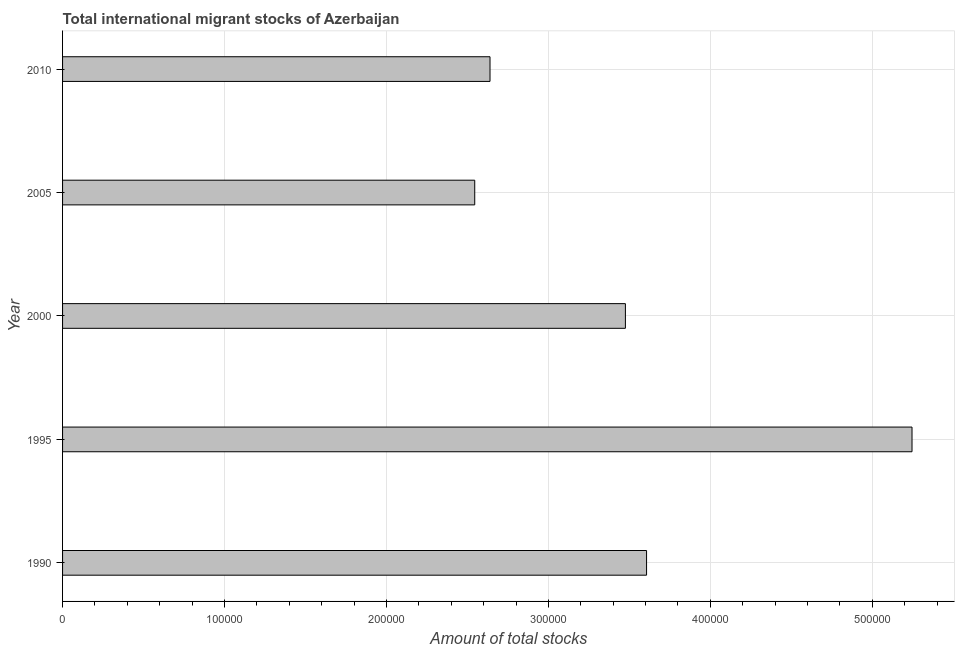Does the graph contain grids?
Offer a terse response. Yes. What is the title of the graph?
Ensure brevity in your answer.  Total international migrant stocks of Azerbaijan. What is the label or title of the X-axis?
Give a very brief answer. Amount of total stocks. What is the total number of international migrant stock in 1990?
Provide a short and direct response. 3.61e+05. Across all years, what is the maximum total number of international migrant stock?
Your answer should be compact. 5.25e+05. Across all years, what is the minimum total number of international migrant stock?
Your answer should be very brief. 2.55e+05. In which year was the total number of international migrant stock minimum?
Your answer should be very brief. 2005. What is the sum of the total number of international migrant stock?
Your answer should be compact. 1.75e+06. What is the difference between the total number of international migrant stock in 2005 and 2010?
Provide a short and direct response. -9431. What is the average total number of international migrant stock per year?
Keep it short and to the point. 3.50e+05. What is the median total number of international migrant stock?
Offer a terse response. 3.48e+05. In how many years, is the total number of international migrant stock greater than 380000 ?
Offer a terse response. 1. What is the ratio of the total number of international migrant stock in 1990 to that in 1995?
Your answer should be very brief. 0.69. Is the total number of international migrant stock in 1995 less than that in 2000?
Offer a very short reply. No. What is the difference between the highest and the second highest total number of international migrant stock?
Provide a succinct answer. 1.64e+05. What is the difference between the highest and the lowest total number of international migrant stock?
Offer a very short reply. 2.70e+05. In how many years, is the total number of international migrant stock greater than the average total number of international migrant stock taken over all years?
Ensure brevity in your answer.  2. How many bars are there?
Your answer should be compact. 5. What is the Amount of total stocks in 1990?
Provide a short and direct response. 3.61e+05. What is the Amount of total stocks of 1995?
Your answer should be very brief. 5.25e+05. What is the Amount of total stocks in 2000?
Make the answer very short. 3.48e+05. What is the Amount of total stocks in 2005?
Provide a succinct answer. 2.55e+05. What is the Amount of total stocks of 2010?
Your answer should be compact. 2.64e+05. What is the difference between the Amount of total stocks in 1990 and 1995?
Your response must be concise. -1.64e+05. What is the difference between the Amount of total stocks in 1990 and 2000?
Offer a terse response. 1.31e+04. What is the difference between the Amount of total stocks in 1990 and 2005?
Offer a terse response. 1.06e+05. What is the difference between the Amount of total stocks in 1990 and 2010?
Ensure brevity in your answer.  9.67e+04. What is the difference between the Amount of total stocks in 1995 and 2000?
Give a very brief answer. 1.77e+05. What is the difference between the Amount of total stocks in 1995 and 2005?
Provide a succinct answer. 2.70e+05. What is the difference between the Amount of total stocks in 1995 and 2010?
Provide a short and direct response. 2.61e+05. What is the difference between the Amount of total stocks in 2000 and 2005?
Your response must be concise. 9.30e+04. What is the difference between the Amount of total stocks in 2000 and 2010?
Provide a succinct answer. 8.36e+04. What is the difference between the Amount of total stocks in 2005 and 2010?
Give a very brief answer. -9431. What is the ratio of the Amount of total stocks in 1990 to that in 1995?
Keep it short and to the point. 0.69. What is the ratio of the Amount of total stocks in 1990 to that in 2000?
Provide a succinct answer. 1.04. What is the ratio of the Amount of total stocks in 1990 to that in 2005?
Give a very brief answer. 1.42. What is the ratio of the Amount of total stocks in 1990 to that in 2010?
Give a very brief answer. 1.37. What is the ratio of the Amount of total stocks in 1995 to that in 2000?
Provide a succinct answer. 1.51. What is the ratio of the Amount of total stocks in 1995 to that in 2005?
Make the answer very short. 2.06. What is the ratio of the Amount of total stocks in 1995 to that in 2010?
Your response must be concise. 1.99. What is the ratio of the Amount of total stocks in 2000 to that in 2005?
Offer a terse response. 1.37. What is the ratio of the Amount of total stocks in 2000 to that in 2010?
Keep it short and to the point. 1.32. 